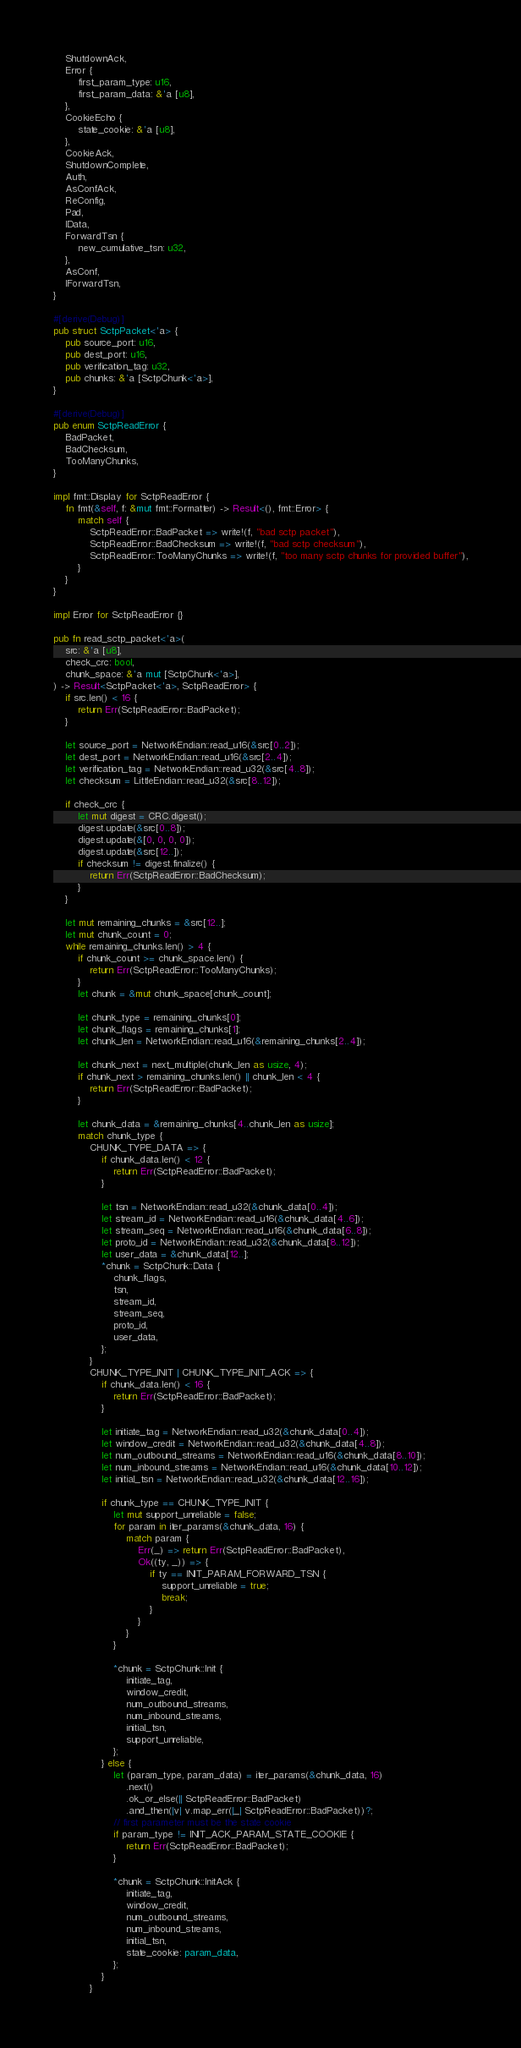<code> <loc_0><loc_0><loc_500><loc_500><_Rust_>    ShutdownAck,
    Error {
        first_param_type: u16,
        first_param_data: &'a [u8],
    },
    CookieEcho {
        state_cookie: &'a [u8],
    },
    CookieAck,
    ShutdownComplete,
    Auth,
    AsConfAck,
    ReConfig,
    Pad,
    IData,
    ForwardTsn {
        new_cumulative_tsn: u32,
    },
    AsConf,
    IForwardTsn,
}

#[derive(Debug)]
pub struct SctpPacket<'a> {
    pub source_port: u16,
    pub dest_port: u16,
    pub verification_tag: u32,
    pub chunks: &'a [SctpChunk<'a>],
}

#[derive(Debug)]
pub enum SctpReadError {
    BadPacket,
    BadChecksum,
    TooManyChunks,
}

impl fmt::Display for SctpReadError {
    fn fmt(&self, f: &mut fmt::Formatter) -> Result<(), fmt::Error> {
        match self {
            SctpReadError::BadPacket => write!(f, "bad sctp packet"),
            SctpReadError::BadChecksum => write!(f, "bad sctp checksum"),
            SctpReadError::TooManyChunks => write!(f, "too many sctp chunks for provided buffer"),
        }
    }
}

impl Error for SctpReadError {}

pub fn read_sctp_packet<'a>(
    src: &'a [u8],
    check_crc: bool,
    chunk_space: &'a mut [SctpChunk<'a>],
) -> Result<SctpPacket<'a>, SctpReadError> {
    if src.len() < 16 {
        return Err(SctpReadError::BadPacket);
    }

    let source_port = NetworkEndian::read_u16(&src[0..2]);
    let dest_port = NetworkEndian::read_u16(&src[2..4]);
    let verification_tag = NetworkEndian::read_u32(&src[4..8]);
    let checksum = LittleEndian::read_u32(&src[8..12]);

    if check_crc {
        let mut digest = CRC.digest();
        digest.update(&src[0..8]);
        digest.update(&[0, 0, 0, 0]);
        digest.update(&src[12..]);
        if checksum != digest.finalize() {
            return Err(SctpReadError::BadChecksum);
        }
    }

    let mut remaining_chunks = &src[12..];
    let mut chunk_count = 0;
    while remaining_chunks.len() > 4 {
        if chunk_count >= chunk_space.len() {
            return Err(SctpReadError::TooManyChunks);
        }
        let chunk = &mut chunk_space[chunk_count];

        let chunk_type = remaining_chunks[0];
        let chunk_flags = remaining_chunks[1];
        let chunk_len = NetworkEndian::read_u16(&remaining_chunks[2..4]);

        let chunk_next = next_multiple(chunk_len as usize, 4);
        if chunk_next > remaining_chunks.len() || chunk_len < 4 {
            return Err(SctpReadError::BadPacket);
        }

        let chunk_data = &remaining_chunks[4..chunk_len as usize];
        match chunk_type {
            CHUNK_TYPE_DATA => {
                if chunk_data.len() < 12 {
                    return Err(SctpReadError::BadPacket);
                }

                let tsn = NetworkEndian::read_u32(&chunk_data[0..4]);
                let stream_id = NetworkEndian::read_u16(&chunk_data[4..6]);
                let stream_seq = NetworkEndian::read_u16(&chunk_data[6..8]);
                let proto_id = NetworkEndian::read_u32(&chunk_data[8..12]);
                let user_data = &chunk_data[12..];
                *chunk = SctpChunk::Data {
                    chunk_flags,
                    tsn,
                    stream_id,
                    stream_seq,
                    proto_id,
                    user_data,
                };
            }
            CHUNK_TYPE_INIT | CHUNK_TYPE_INIT_ACK => {
                if chunk_data.len() < 16 {
                    return Err(SctpReadError::BadPacket);
                }

                let initiate_tag = NetworkEndian::read_u32(&chunk_data[0..4]);
                let window_credit = NetworkEndian::read_u32(&chunk_data[4..8]);
                let num_outbound_streams = NetworkEndian::read_u16(&chunk_data[8..10]);
                let num_inbound_streams = NetworkEndian::read_u16(&chunk_data[10..12]);
                let initial_tsn = NetworkEndian::read_u32(&chunk_data[12..16]);

                if chunk_type == CHUNK_TYPE_INIT {
                    let mut support_unreliable = false;
                    for param in iter_params(&chunk_data, 16) {
                        match param {
                            Err(_) => return Err(SctpReadError::BadPacket),
                            Ok((ty, _)) => {
                                if ty == INIT_PARAM_FORWARD_TSN {
                                    support_unreliable = true;
                                    break;
                                }
                            }
                        }
                    }

                    *chunk = SctpChunk::Init {
                        initiate_tag,
                        window_credit,
                        num_outbound_streams,
                        num_inbound_streams,
                        initial_tsn,
                        support_unreliable,
                    };
                } else {
                    let (param_type, param_data) = iter_params(&chunk_data, 16)
                        .next()
                        .ok_or_else(|| SctpReadError::BadPacket)
                        .and_then(|v| v.map_err(|_| SctpReadError::BadPacket))?;
                    // first parameter must be the state cookie
                    if param_type != INIT_ACK_PARAM_STATE_COOKIE {
                        return Err(SctpReadError::BadPacket);
                    }

                    *chunk = SctpChunk::InitAck {
                        initiate_tag,
                        window_credit,
                        num_outbound_streams,
                        num_inbound_streams,
                        initial_tsn,
                        state_cookie: param_data,
                    };
                }
            }</code> 